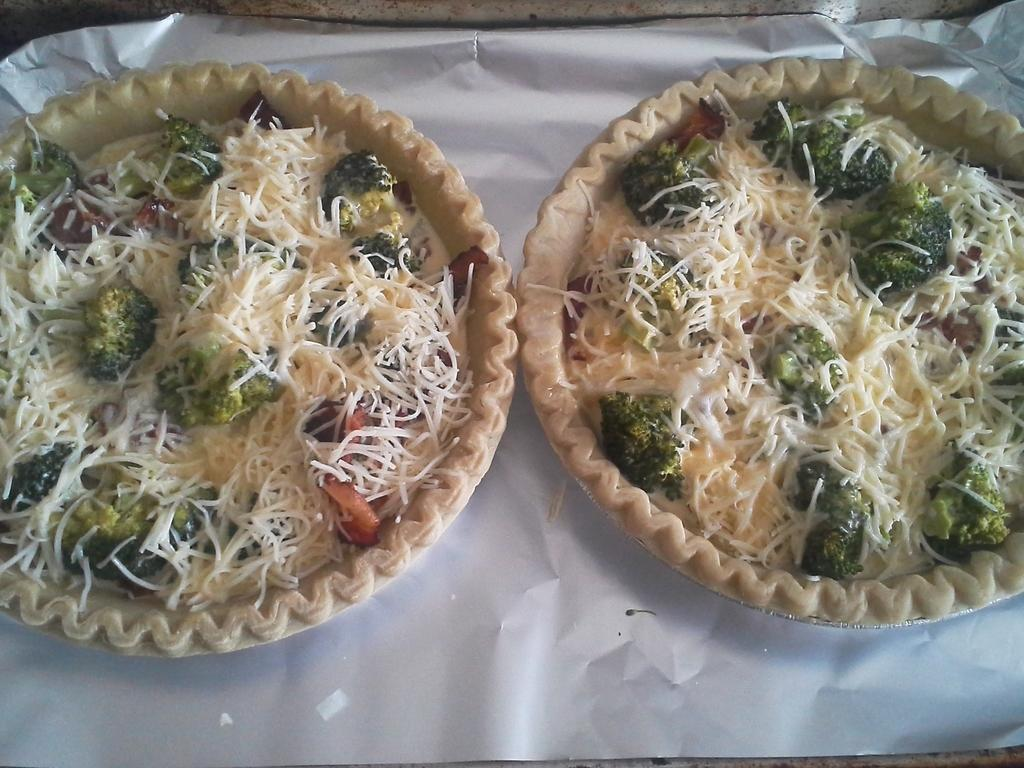What is present on the table in the image? There are plates of food in the image. Where is the table located in relation to the image? The table is located in the center of the image. What type of owl can be seen sitting on the woman's shoulder in the image? There is no owl or woman present in the image; it only features plates of food on a table. 